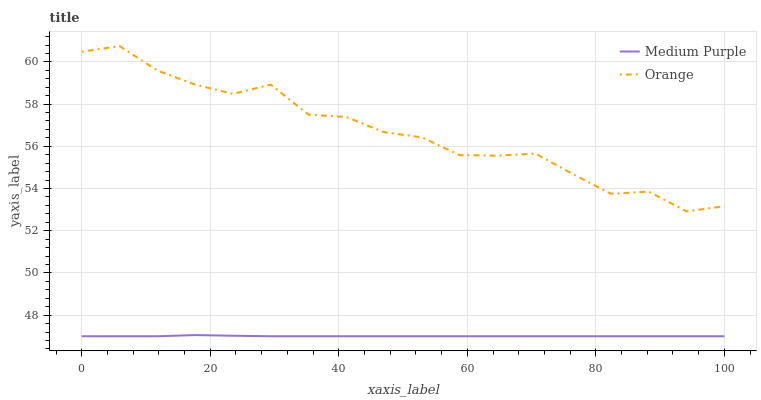Does Medium Purple have the minimum area under the curve?
Answer yes or no. Yes. Does Orange have the maximum area under the curve?
Answer yes or no. Yes. Does Orange have the minimum area under the curve?
Answer yes or no. No. Is Medium Purple the smoothest?
Answer yes or no. Yes. Is Orange the roughest?
Answer yes or no. Yes. Is Orange the smoothest?
Answer yes or no. No. Does Medium Purple have the lowest value?
Answer yes or no. Yes. Does Orange have the lowest value?
Answer yes or no. No. Does Orange have the highest value?
Answer yes or no. Yes. Is Medium Purple less than Orange?
Answer yes or no. Yes. Is Orange greater than Medium Purple?
Answer yes or no. Yes. Does Medium Purple intersect Orange?
Answer yes or no. No. 